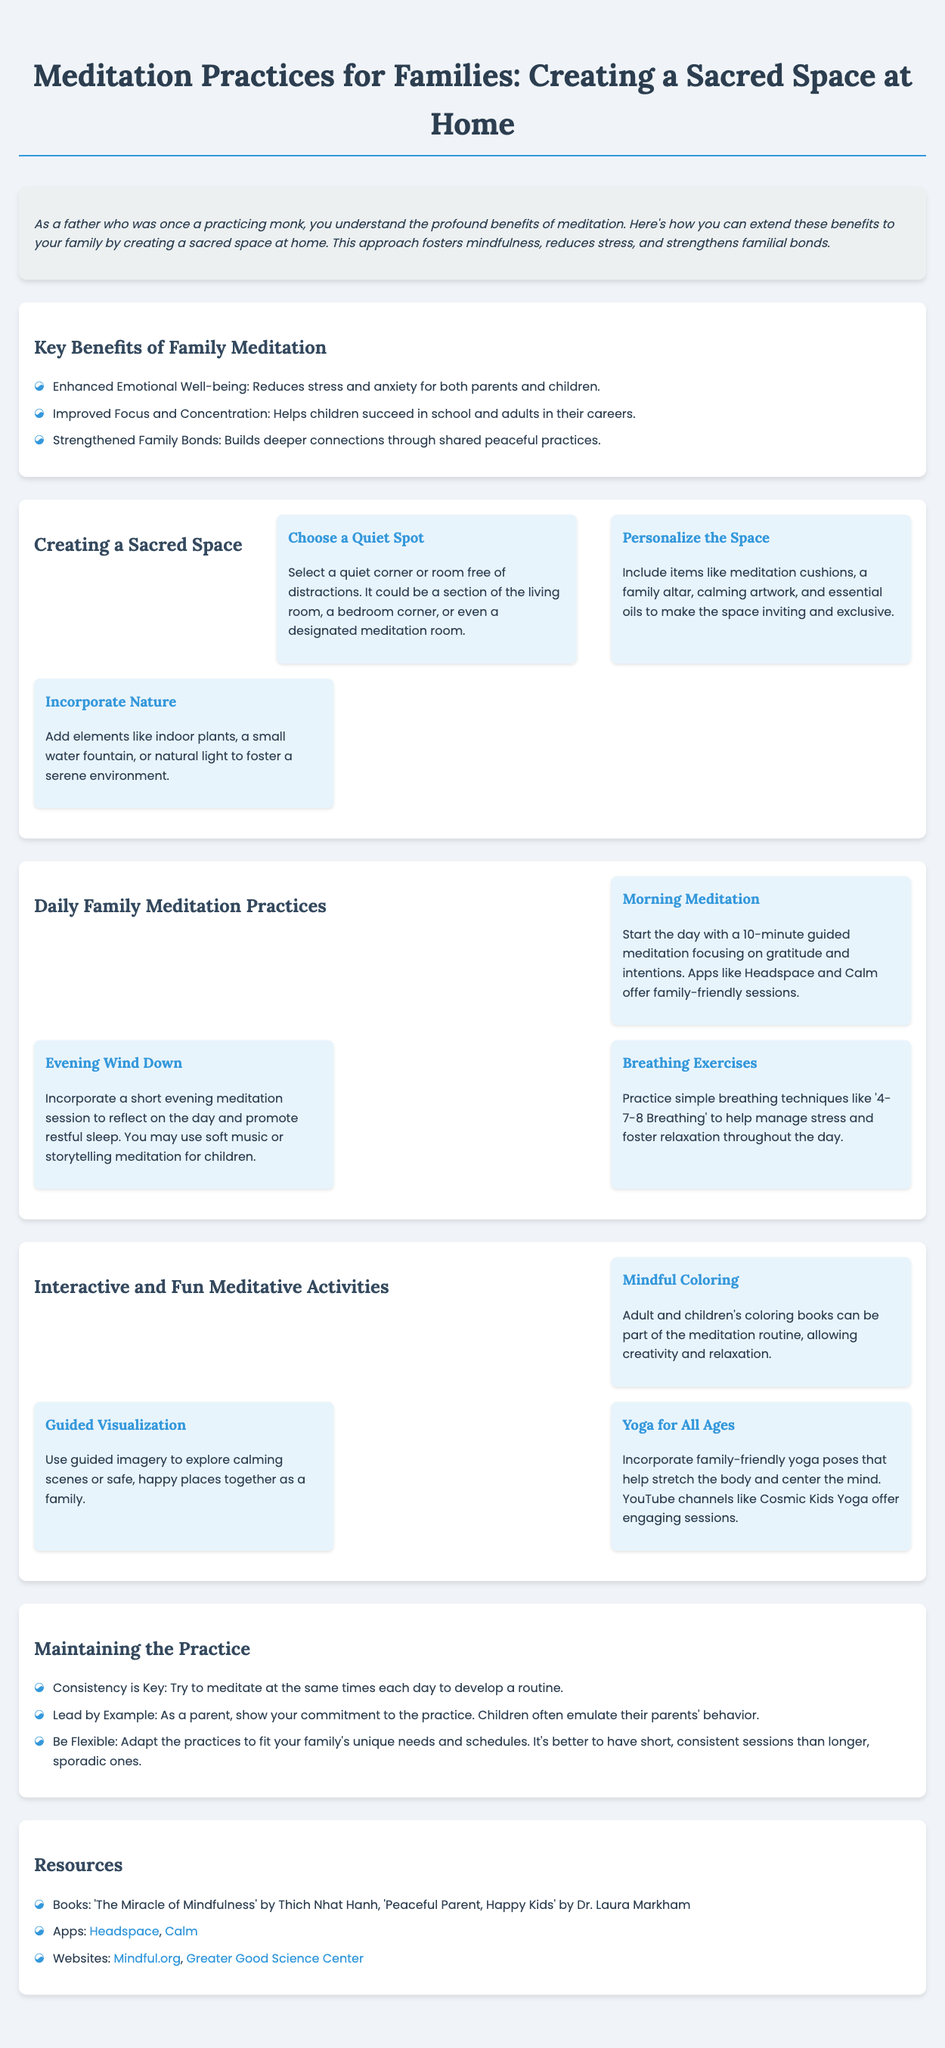What are the key benefits of family meditation? The benefits listed include emotional well-being, focus, and family bonds.
Answer: Emotional well-being, focus, family bonds What should be included in a personalized sacred space? The document mentions items to make the space inviting and exclusive, such as cushions and artwork.
Answer: Meditation cushions, family altar, calming artwork, essential oils What is the recommended duration for morning meditation? The document specifies starting the day with a 10-minute guided meditation.
Answer: 10 minutes Which app is suggested for guided meditation? The document recommends apps like Headspace and Calm for family-friendly sessions.
Answer: Headspace, Calm What activity involves creativity and relaxation? The document lists mindful coloring as an interactive activity for families.
Answer: Mindful Coloring What is a key aspect in maintaining meditation practice? The document emphasizes that consistency in timing is crucial for developing a routine.
Answer: Consistency What type of yoga is suggested for all ages? The document mentions family-friendly yoga poses for stretching and centering.
Answer: Yoga for All Ages What is the main purpose of creating a sacred space at home? The paragraph explains that it fosters mindfulness, reduces stress, and strengthens bonds.
Answer: Foster mindfulness, reduce stress, strengthen bonds How does the infographic suggest reflecting on the day? It recommends incorporating a short evening meditation session.
Answer: Short evening meditation session 